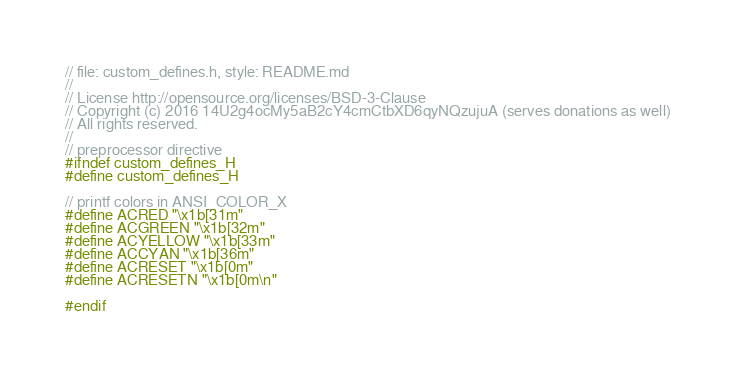<code> <loc_0><loc_0><loc_500><loc_500><_C_>// file: custom_defines.h, style: README.md
//
// License http://opensource.org/licenses/BSD-3-Clause
// Copyright (c) 2016 14U2g4ocMy5aB2cY4cmCtbXD6qyNQzujuA (serves donations as well)
// All rights reserved.
//
// preprocessor directive
#ifndef custom_defines_H
#define custom_defines_H

// printf colors in ANSI_COLOR_X
#define ACRED "\x1b[31m"
#define ACGREEN "\x1b[32m"
#define ACYELLOW "\x1b[33m"
#define ACCYAN "\x1b[36m"
#define ACRESET "\x1b[0m"
#define ACRESETN "\x1b[0m\n"

#endif
</code> 